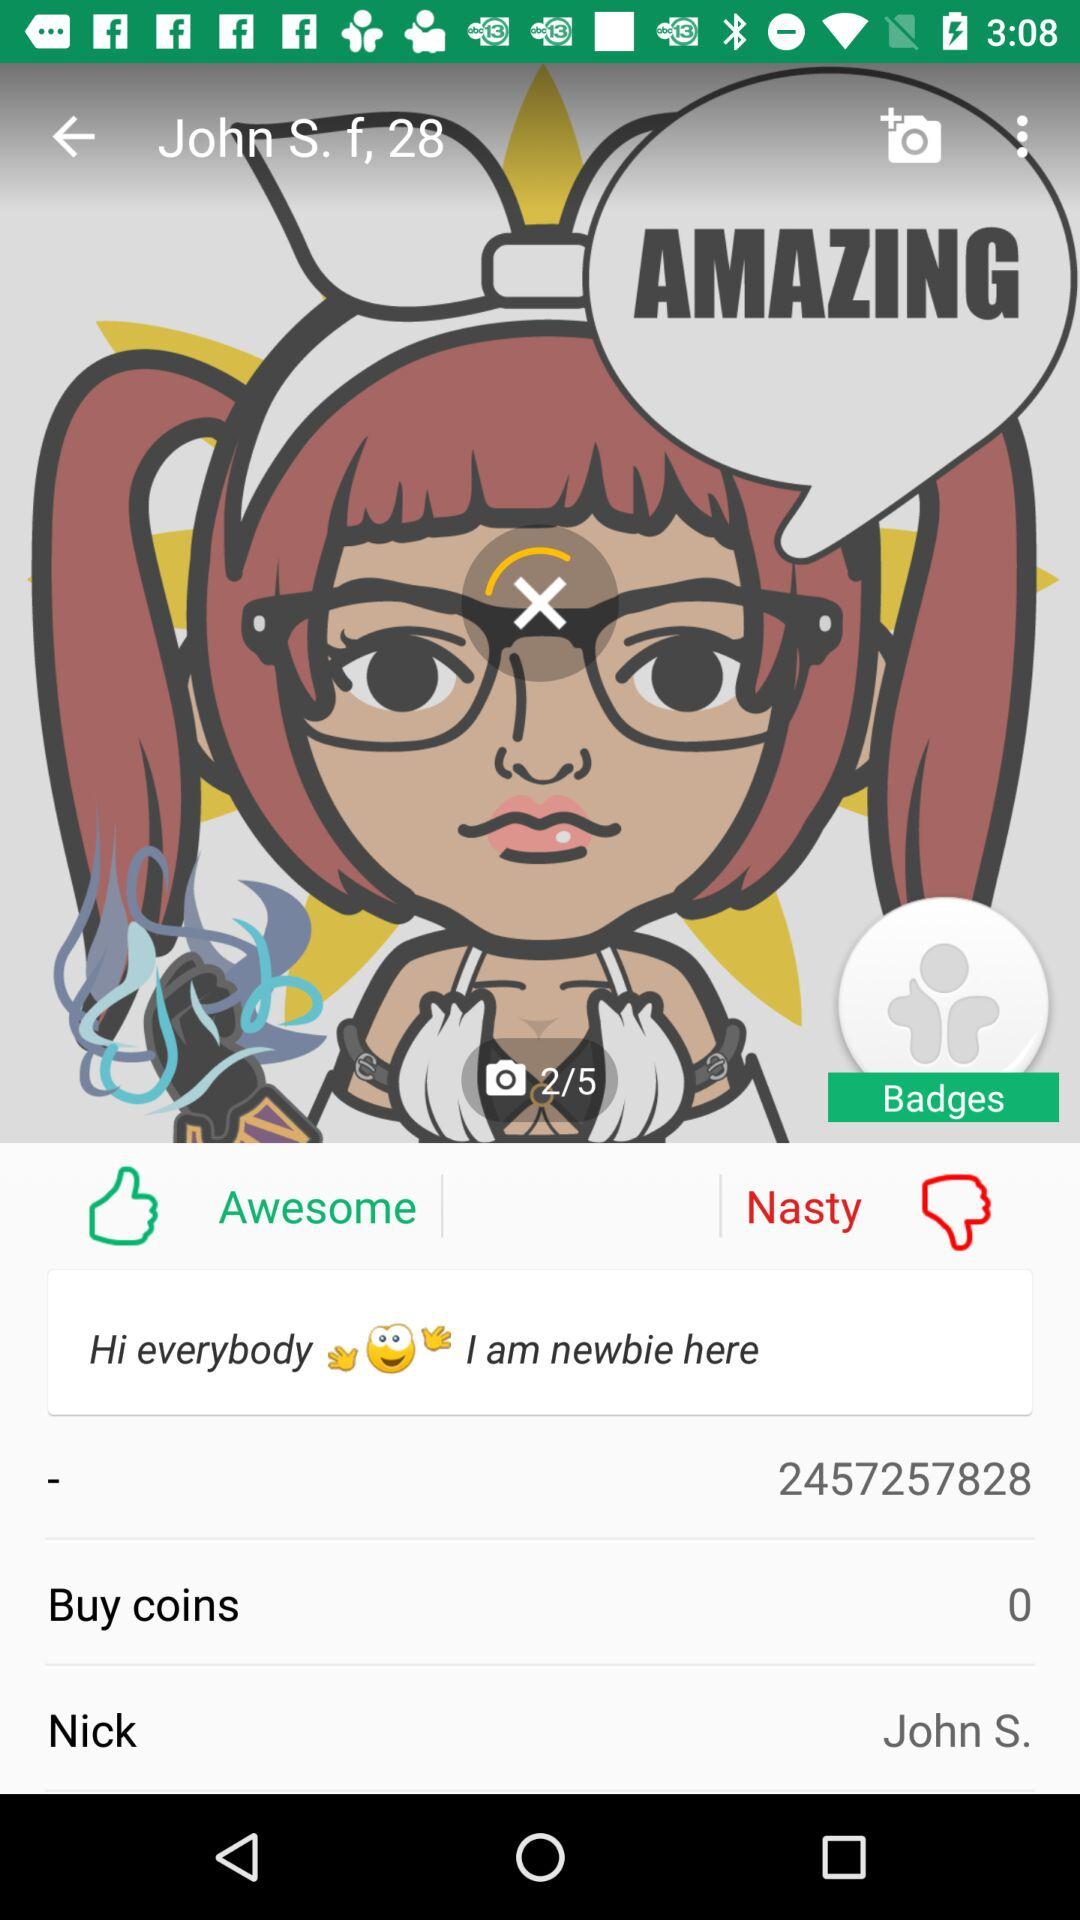What is the name of the application?
When the provided information is insufficient, respond with <no answer>. <no answer> 